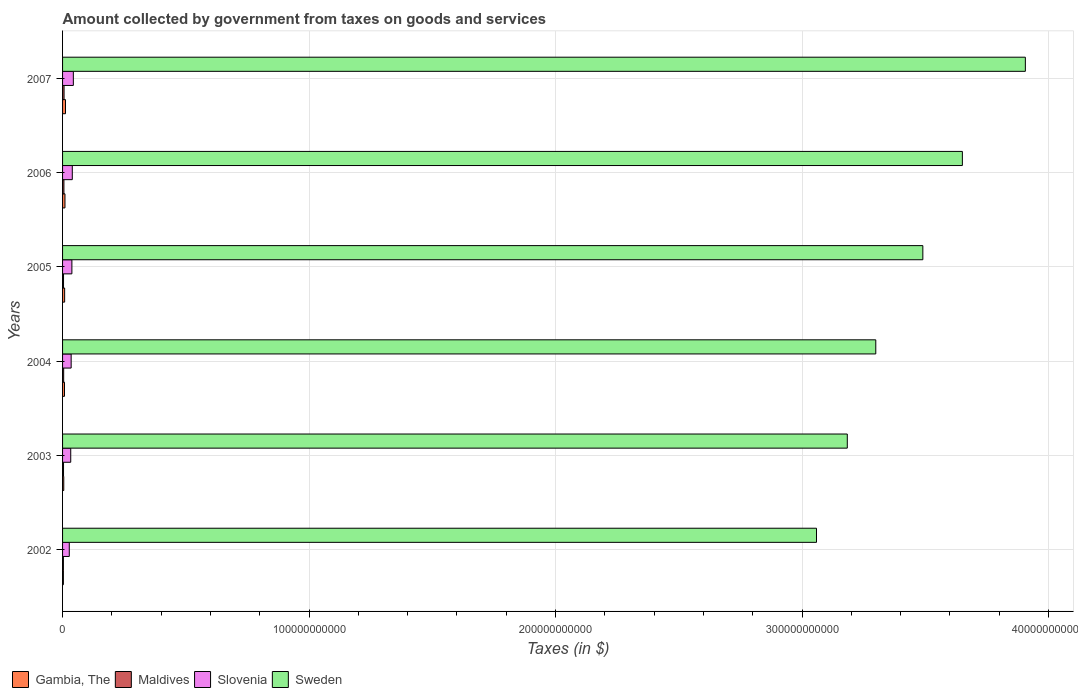How many groups of bars are there?
Your answer should be compact. 6. Are the number of bars per tick equal to the number of legend labels?
Provide a succinct answer. Yes. What is the label of the 4th group of bars from the top?
Give a very brief answer. 2004. In how many cases, is the number of bars for a given year not equal to the number of legend labels?
Your response must be concise. 0. What is the amount collected by government from taxes on goods and services in Maldives in 2005?
Keep it short and to the point. 3.91e+08. Across all years, what is the maximum amount collected by government from taxes on goods and services in Gambia, The?
Your answer should be compact. 1.19e+09. Across all years, what is the minimum amount collected by government from taxes on goods and services in Sweden?
Provide a succinct answer. 3.06e+11. In which year was the amount collected by government from taxes on goods and services in Maldives maximum?
Give a very brief answer. 2007. What is the total amount collected by government from taxes on goods and services in Sweden in the graph?
Provide a short and direct response. 2.06e+12. What is the difference between the amount collected by government from taxes on goods and services in Maldives in 2002 and that in 2005?
Your answer should be very brief. -5.26e+07. What is the difference between the amount collected by government from taxes on goods and services in Slovenia in 2005 and the amount collected by government from taxes on goods and services in Sweden in 2003?
Keep it short and to the point. -3.15e+11. What is the average amount collected by government from taxes on goods and services in Slovenia per year?
Offer a very short reply. 3.60e+09. In the year 2004, what is the difference between the amount collected by government from taxes on goods and services in Gambia, The and amount collected by government from taxes on goods and services in Sweden?
Provide a succinct answer. -3.29e+11. In how many years, is the amount collected by government from taxes on goods and services in Gambia, The greater than 300000000000 $?
Offer a terse response. 0. What is the ratio of the amount collected by government from taxes on goods and services in Sweden in 2003 to that in 2007?
Provide a succinct answer. 0.82. Is the amount collected by government from taxes on goods and services in Maldives in 2002 less than that in 2006?
Your response must be concise. Yes. What is the difference between the highest and the second highest amount collected by government from taxes on goods and services in Slovenia?
Keep it short and to the point. 4.23e+08. What is the difference between the highest and the lowest amount collected by government from taxes on goods and services in Maldives?
Ensure brevity in your answer.  2.69e+08. What does the 1st bar from the top in 2002 represents?
Your response must be concise. Sweden. What does the 4th bar from the bottom in 2003 represents?
Provide a short and direct response. Sweden. How many years are there in the graph?
Offer a very short reply. 6. What is the difference between two consecutive major ticks on the X-axis?
Your response must be concise. 1.00e+11. Are the values on the major ticks of X-axis written in scientific E-notation?
Provide a succinct answer. No. Does the graph contain grids?
Your answer should be very brief. Yes. Where does the legend appear in the graph?
Provide a short and direct response. Bottom left. How many legend labels are there?
Offer a very short reply. 4. What is the title of the graph?
Provide a short and direct response. Amount collected by government from taxes on goods and services. Does "Lebanon" appear as one of the legend labels in the graph?
Make the answer very short. No. What is the label or title of the X-axis?
Your answer should be very brief. Taxes (in $). What is the label or title of the Y-axis?
Your answer should be very brief. Years. What is the Taxes (in $) in Gambia, The in 2002?
Offer a terse response. 3.34e+08. What is the Taxes (in $) of Maldives in 2002?
Provide a short and direct response. 3.39e+08. What is the Taxes (in $) in Slovenia in 2002?
Keep it short and to the point. 2.72e+09. What is the Taxes (in $) in Sweden in 2002?
Ensure brevity in your answer.  3.06e+11. What is the Taxes (in $) of Gambia, The in 2003?
Provide a short and direct response. 4.84e+08. What is the Taxes (in $) in Maldives in 2003?
Ensure brevity in your answer.  3.95e+08. What is the Taxes (in $) of Slovenia in 2003?
Keep it short and to the point. 3.31e+09. What is the Taxes (in $) of Sweden in 2003?
Offer a terse response. 3.18e+11. What is the Taxes (in $) in Gambia, The in 2004?
Offer a very short reply. 7.87e+08. What is the Taxes (in $) of Maldives in 2004?
Ensure brevity in your answer.  4.50e+08. What is the Taxes (in $) in Slovenia in 2004?
Provide a succinct answer. 3.49e+09. What is the Taxes (in $) of Sweden in 2004?
Your answer should be compact. 3.30e+11. What is the Taxes (in $) of Gambia, The in 2005?
Your response must be concise. 8.43e+08. What is the Taxes (in $) in Maldives in 2005?
Ensure brevity in your answer.  3.91e+08. What is the Taxes (in $) of Slovenia in 2005?
Provide a succinct answer. 3.78e+09. What is the Taxes (in $) of Sweden in 2005?
Offer a terse response. 3.49e+11. What is the Taxes (in $) in Gambia, The in 2006?
Offer a very short reply. 9.76e+08. What is the Taxes (in $) of Maldives in 2006?
Your answer should be very brief. 5.49e+08. What is the Taxes (in $) in Slovenia in 2006?
Offer a very short reply. 3.95e+09. What is the Taxes (in $) in Sweden in 2006?
Your answer should be compact. 3.65e+11. What is the Taxes (in $) in Gambia, The in 2007?
Offer a very short reply. 1.19e+09. What is the Taxes (in $) of Maldives in 2007?
Provide a short and direct response. 6.08e+08. What is the Taxes (in $) in Slovenia in 2007?
Provide a succinct answer. 4.37e+09. What is the Taxes (in $) in Sweden in 2007?
Keep it short and to the point. 3.91e+11. Across all years, what is the maximum Taxes (in $) of Gambia, The?
Give a very brief answer. 1.19e+09. Across all years, what is the maximum Taxes (in $) in Maldives?
Provide a succinct answer. 6.08e+08. Across all years, what is the maximum Taxes (in $) of Slovenia?
Offer a terse response. 4.37e+09. Across all years, what is the maximum Taxes (in $) of Sweden?
Your response must be concise. 3.91e+11. Across all years, what is the minimum Taxes (in $) of Gambia, The?
Ensure brevity in your answer.  3.34e+08. Across all years, what is the minimum Taxes (in $) of Maldives?
Provide a short and direct response. 3.39e+08. Across all years, what is the minimum Taxes (in $) in Slovenia?
Provide a succinct answer. 2.72e+09. Across all years, what is the minimum Taxes (in $) of Sweden?
Ensure brevity in your answer.  3.06e+11. What is the total Taxes (in $) in Gambia, The in the graph?
Provide a succinct answer. 4.62e+09. What is the total Taxes (in $) of Maldives in the graph?
Make the answer very short. 2.73e+09. What is the total Taxes (in $) of Slovenia in the graph?
Ensure brevity in your answer.  2.16e+1. What is the total Taxes (in $) in Sweden in the graph?
Offer a very short reply. 2.06e+12. What is the difference between the Taxes (in $) of Gambia, The in 2002 and that in 2003?
Make the answer very short. -1.50e+08. What is the difference between the Taxes (in $) in Maldives in 2002 and that in 2003?
Your response must be concise. -5.62e+07. What is the difference between the Taxes (in $) of Slovenia in 2002 and that in 2003?
Make the answer very short. -5.88e+08. What is the difference between the Taxes (in $) in Sweden in 2002 and that in 2003?
Offer a terse response. -1.25e+1. What is the difference between the Taxes (in $) of Gambia, The in 2002 and that in 2004?
Make the answer very short. -4.52e+08. What is the difference between the Taxes (in $) of Maldives in 2002 and that in 2004?
Your answer should be compact. -1.12e+08. What is the difference between the Taxes (in $) in Slovenia in 2002 and that in 2004?
Make the answer very short. -7.65e+08. What is the difference between the Taxes (in $) in Sweden in 2002 and that in 2004?
Make the answer very short. -2.41e+1. What is the difference between the Taxes (in $) of Gambia, The in 2002 and that in 2005?
Make the answer very short. -5.09e+08. What is the difference between the Taxes (in $) of Maldives in 2002 and that in 2005?
Provide a succinct answer. -5.26e+07. What is the difference between the Taxes (in $) in Slovenia in 2002 and that in 2005?
Your answer should be compact. -1.06e+09. What is the difference between the Taxes (in $) in Sweden in 2002 and that in 2005?
Offer a very short reply. -4.31e+1. What is the difference between the Taxes (in $) of Gambia, The in 2002 and that in 2006?
Provide a succinct answer. -6.41e+08. What is the difference between the Taxes (in $) in Maldives in 2002 and that in 2006?
Your answer should be compact. -2.11e+08. What is the difference between the Taxes (in $) in Slovenia in 2002 and that in 2006?
Make the answer very short. -1.23e+09. What is the difference between the Taxes (in $) of Sweden in 2002 and that in 2006?
Provide a succinct answer. -5.92e+1. What is the difference between the Taxes (in $) in Gambia, The in 2002 and that in 2007?
Your response must be concise. -8.58e+08. What is the difference between the Taxes (in $) of Maldives in 2002 and that in 2007?
Your answer should be very brief. -2.69e+08. What is the difference between the Taxes (in $) of Slovenia in 2002 and that in 2007?
Your answer should be very brief. -1.65e+09. What is the difference between the Taxes (in $) in Sweden in 2002 and that in 2007?
Your response must be concise. -8.47e+1. What is the difference between the Taxes (in $) in Gambia, The in 2003 and that in 2004?
Ensure brevity in your answer.  -3.03e+08. What is the difference between the Taxes (in $) of Maldives in 2003 and that in 2004?
Offer a terse response. -5.57e+07. What is the difference between the Taxes (in $) of Slovenia in 2003 and that in 2004?
Provide a short and direct response. -1.77e+08. What is the difference between the Taxes (in $) of Sweden in 2003 and that in 2004?
Make the answer very short. -1.16e+1. What is the difference between the Taxes (in $) in Gambia, The in 2003 and that in 2005?
Provide a short and direct response. -3.59e+08. What is the difference between the Taxes (in $) in Maldives in 2003 and that in 2005?
Offer a very short reply. 3.60e+06. What is the difference between the Taxes (in $) in Slovenia in 2003 and that in 2005?
Ensure brevity in your answer.  -4.72e+08. What is the difference between the Taxes (in $) in Sweden in 2003 and that in 2005?
Ensure brevity in your answer.  -3.07e+1. What is the difference between the Taxes (in $) of Gambia, The in 2003 and that in 2006?
Give a very brief answer. -4.91e+08. What is the difference between the Taxes (in $) in Maldives in 2003 and that in 2006?
Offer a very short reply. -1.55e+08. What is the difference between the Taxes (in $) of Slovenia in 2003 and that in 2006?
Provide a succinct answer. -6.40e+08. What is the difference between the Taxes (in $) in Sweden in 2003 and that in 2006?
Your answer should be very brief. -4.67e+1. What is the difference between the Taxes (in $) of Gambia, The in 2003 and that in 2007?
Your answer should be very brief. -7.08e+08. What is the difference between the Taxes (in $) of Maldives in 2003 and that in 2007?
Your answer should be very brief. -2.13e+08. What is the difference between the Taxes (in $) of Slovenia in 2003 and that in 2007?
Make the answer very short. -1.06e+09. What is the difference between the Taxes (in $) in Sweden in 2003 and that in 2007?
Provide a succinct answer. -7.22e+1. What is the difference between the Taxes (in $) in Gambia, The in 2004 and that in 2005?
Your answer should be very brief. -5.66e+07. What is the difference between the Taxes (in $) of Maldives in 2004 and that in 2005?
Your answer should be compact. 5.93e+07. What is the difference between the Taxes (in $) of Slovenia in 2004 and that in 2005?
Your response must be concise. -2.96e+08. What is the difference between the Taxes (in $) in Sweden in 2004 and that in 2005?
Your response must be concise. -1.91e+1. What is the difference between the Taxes (in $) of Gambia, The in 2004 and that in 2006?
Give a very brief answer. -1.89e+08. What is the difference between the Taxes (in $) in Maldives in 2004 and that in 2006?
Keep it short and to the point. -9.89e+07. What is the difference between the Taxes (in $) in Slovenia in 2004 and that in 2006?
Provide a succinct answer. -4.63e+08. What is the difference between the Taxes (in $) of Sweden in 2004 and that in 2006?
Your answer should be compact. -3.51e+1. What is the difference between the Taxes (in $) in Gambia, The in 2004 and that in 2007?
Provide a short and direct response. -4.06e+08. What is the difference between the Taxes (in $) in Maldives in 2004 and that in 2007?
Make the answer very short. -1.57e+08. What is the difference between the Taxes (in $) of Slovenia in 2004 and that in 2007?
Offer a terse response. -8.86e+08. What is the difference between the Taxes (in $) of Sweden in 2004 and that in 2007?
Your answer should be very brief. -6.07e+1. What is the difference between the Taxes (in $) in Gambia, The in 2005 and that in 2006?
Provide a succinct answer. -1.32e+08. What is the difference between the Taxes (in $) of Maldives in 2005 and that in 2006?
Offer a terse response. -1.58e+08. What is the difference between the Taxes (in $) in Slovenia in 2005 and that in 2006?
Give a very brief answer. -1.67e+08. What is the difference between the Taxes (in $) of Sweden in 2005 and that in 2006?
Offer a terse response. -1.60e+1. What is the difference between the Taxes (in $) of Gambia, The in 2005 and that in 2007?
Offer a very short reply. -3.49e+08. What is the difference between the Taxes (in $) in Maldives in 2005 and that in 2007?
Make the answer very short. -2.17e+08. What is the difference between the Taxes (in $) in Slovenia in 2005 and that in 2007?
Your answer should be compact. -5.90e+08. What is the difference between the Taxes (in $) of Sweden in 2005 and that in 2007?
Provide a succinct answer. -4.16e+1. What is the difference between the Taxes (in $) in Gambia, The in 2006 and that in 2007?
Offer a terse response. -2.17e+08. What is the difference between the Taxes (in $) in Maldives in 2006 and that in 2007?
Provide a succinct answer. -5.84e+07. What is the difference between the Taxes (in $) in Slovenia in 2006 and that in 2007?
Your answer should be very brief. -4.23e+08. What is the difference between the Taxes (in $) in Sweden in 2006 and that in 2007?
Provide a succinct answer. -2.55e+1. What is the difference between the Taxes (in $) of Gambia, The in 2002 and the Taxes (in $) of Maldives in 2003?
Provide a succinct answer. -6.03e+07. What is the difference between the Taxes (in $) of Gambia, The in 2002 and the Taxes (in $) of Slovenia in 2003?
Your answer should be very brief. -2.98e+09. What is the difference between the Taxes (in $) of Gambia, The in 2002 and the Taxes (in $) of Sweden in 2003?
Your answer should be very brief. -3.18e+11. What is the difference between the Taxes (in $) of Maldives in 2002 and the Taxes (in $) of Slovenia in 2003?
Offer a terse response. -2.97e+09. What is the difference between the Taxes (in $) of Maldives in 2002 and the Taxes (in $) of Sweden in 2003?
Give a very brief answer. -3.18e+11. What is the difference between the Taxes (in $) of Slovenia in 2002 and the Taxes (in $) of Sweden in 2003?
Offer a terse response. -3.16e+11. What is the difference between the Taxes (in $) in Gambia, The in 2002 and the Taxes (in $) in Maldives in 2004?
Your response must be concise. -1.16e+08. What is the difference between the Taxes (in $) of Gambia, The in 2002 and the Taxes (in $) of Slovenia in 2004?
Give a very brief answer. -3.15e+09. What is the difference between the Taxes (in $) of Gambia, The in 2002 and the Taxes (in $) of Sweden in 2004?
Give a very brief answer. -3.30e+11. What is the difference between the Taxes (in $) in Maldives in 2002 and the Taxes (in $) in Slovenia in 2004?
Give a very brief answer. -3.15e+09. What is the difference between the Taxes (in $) in Maldives in 2002 and the Taxes (in $) in Sweden in 2004?
Provide a short and direct response. -3.30e+11. What is the difference between the Taxes (in $) in Slovenia in 2002 and the Taxes (in $) in Sweden in 2004?
Provide a short and direct response. -3.27e+11. What is the difference between the Taxes (in $) of Gambia, The in 2002 and the Taxes (in $) of Maldives in 2005?
Ensure brevity in your answer.  -5.67e+07. What is the difference between the Taxes (in $) in Gambia, The in 2002 and the Taxes (in $) in Slovenia in 2005?
Keep it short and to the point. -3.45e+09. What is the difference between the Taxes (in $) of Gambia, The in 2002 and the Taxes (in $) of Sweden in 2005?
Offer a very short reply. -3.49e+11. What is the difference between the Taxes (in $) of Maldives in 2002 and the Taxes (in $) of Slovenia in 2005?
Provide a short and direct response. -3.44e+09. What is the difference between the Taxes (in $) in Maldives in 2002 and the Taxes (in $) in Sweden in 2005?
Provide a short and direct response. -3.49e+11. What is the difference between the Taxes (in $) of Slovenia in 2002 and the Taxes (in $) of Sweden in 2005?
Offer a very short reply. -3.46e+11. What is the difference between the Taxes (in $) in Gambia, The in 2002 and the Taxes (in $) in Maldives in 2006?
Your response must be concise. -2.15e+08. What is the difference between the Taxes (in $) of Gambia, The in 2002 and the Taxes (in $) of Slovenia in 2006?
Your response must be concise. -3.62e+09. What is the difference between the Taxes (in $) in Gambia, The in 2002 and the Taxes (in $) in Sweden in 2006?
Offer a terse response. -3.65e+11. What is the difference between the Taxes (in $) of Maldives in 2002 and the Taxes (in $) of Slovenia in 2006?
Offer a terse response. -3.61e+09. What is the difference between the Taxes (in $) of Maldives in 2002 and the Taxes (in $) of Sweden in 2006?
Offer a terse response. -3.65e+11. What is the difference between the Taxes (in $) in Slovenia in 2002 and the Taxes (in $) in Sweden in 2006?
Offer a terse response. -3.62e+11. What is the difference between the Taxes (in $) of Gambia, The in 2002 and the Taxes (in $) of Maldives in 2007?
Give a very brief answer. -2.73e+08. What is the difference between the Taxes (in $) of Gambia, The in 2002 and the Taxes (in $) of Slovenia in 2007?
Keep it short and to the point. -4.04e+09. What is the difference between the Taxes (in $) in Gambia, The in 2002 and the Taxes (in $) in Sweden in 2007?
Keep it short and to the point. -3.90e+11. What is the difference between the Taxes (in $) of Maldives in 2002 and the Taxes (in $) of Slovenia in 2007?
Provide a short and direct response. -4.04e+09. What is the difference between the Taxes (in $) in Maldives in 2002 and the Taxes (in $) in Sweden in 2007?
Offer a terse response. -3.90e+11. What is the difference between the Taxes (in $) of Slovenia in 2002 and the Taxes (in $) of Sweden in 2007?
Provide a succinct answer. -3.88e+11. What is the difference between the Taxes (in $) of Gambia, The in 2003 and the Taxes (in $) of Maldives in 2004?
Your answer should be compact. 3.37e+07. What is the difference between the Taxes (in $) of Gambia, The in 2003 and the Taxes (in $) of Slovenia in 2004?
Give a very brief answer. -3.00e+09. What is the difference between the Taxes (in $) of Gambia, The in 2003 and the Taxes (in $) of Sweden in 2004?
Provide a short and direct response. -3.29e+11. What is the difference between the Taxes (in $) in Maldives in 2003 and the Taxes (in $) in Slovenia in 2004?
Your answer should be compact. -3.09e+09. What is the difference between the Taxes (in $) of Maldives in 2003 and the Taxes (in $) of Sweden in 2004?
Your response must be concise. -3.30e+11. What is the difference between the Taxes (in $) in Slovenia in 2003 and the Taxes (in $) in Sweden in 2004?
Your response must be concise. -3.27e+11. What is the difference between the Taxes (in $) of Gambia, The in 2003 and the Taxes (in $) of Maldives in 2005?
Keep it short and to the point. 9.30e+07. What is the difference between the Taxes (in $) of Gambia, The in 2003 and the Taxes (in $) of Slovenia in 2005?
Make the answer very short. -3.30e+09. What is the difference between the Taxes (in $) of Gambia, The in 2003 and the Taxes (in $) of Sweden in 2005?
Provide a succinct answer. -3.49e+11. What is the difference between the Taxes (in $) of Maldives in 2003 and the Taxes (in $) of Slovenia in 2005?
Offer a very short reply. -3.39e+09. What is the difference between the Taxes (in $) of Maldives in 2003 and the Taxes (in $) of Sweden in 2005?
Offer a terse response. -3.49e+11. What is the difference between the Taxes (in $) in Slovenia in 2003 and the Taxes (in $) in Sweden in 2005?
Keep it short and to the point. -3.46e+11. What is the difference between the Taxes (in $) in Gambia, The in 2003 and the Taxes (in $) in Maldives in 2006?
Keep it short and to the point. -6.52e+07. What is the difference between the Taxes (in $) in Gambia, The in 2003 and the Taxes (in $) in Slovenia in 2006?
Provide a short and direct response. -3.47e+09. What is the difference between the Taxes (in $) of Gambia, The in 2003 and the Taxes (in $) of Sweden in 2006?
Give a very brief answer. -3.65e+11. What is the difference between the Taxes (in $) of Maldives in 2003 and the Taxes (in $) of Slovenia in 2006?
Offer a terse response. -3.56e+09. What is the difference between the Taxes (in $) in Maldives in 2003 and the Taxes (in $) in Sweden in 2006?
Make the answer very short. -3.65e+11. What is the difference between the Taxes (in $) of Slovenia in 2003 and the Taxes (in $) of Sweden in 2006?
Your answer should be very brief. -3.62e+11. What is the difference between the Taxes (in $) in Gambia, The in 2003 and the Taxes (in $) in Maldives in 2007?
Offer a terse response. -1.24e+08. What is the difference between the Taxes (in $) of Gambia, The in 2003 and the Taxes (in $) of Slovenia in 2007?
Your answer should be compact. -3.89e+09. What is the difference between the Taxes (in $) in Gambia, The in 2003 and the Taxes (in $) in Sweden in 2007?
Your answer should be compact. -3.90e+11. What is the difference between the Taxes (in $) of Maldives in 2003 and the Taxes (in $) of Slovenia in 2007?
Ensure brevity in your answer.  -3.98e+09. What is the difference between the Taxes (in $) in Maldives in 2003 and the Taxes (in $) in Sweden in 2007?
Provide a succinct answer. -3.90e+11. What is the difference between the Taxes (in $) in Slovenia in 2003 and the Taxes (in $) in Sweden in 2007?
Ensure brevity in your answer.  -3.87e+11. What is the difference between the Taxes (in $) of Gambia, The in 2004 and the Taxes (in $) of Maldives in 2005?
Your response must be concise. 3.96e+08. What is the difference between the Taxes (in $) of Gambia, The in 2004 and the Taxes (in $) of Slovenia in 2005?
Provide a short and direct response. -3.00e+09. What is the difference between the Taxes (in $) in Gambia, The in 2004 and the Taxes (in $) in Sweden in 2005?
Offer a very short reply. -3.48e+11. What is the difference between the Taxes (in $) in Maldives in 2004 and the Taxes (in $) in Slovenia in 2005?
Provide a short and direct response. -3.33e+09. What is the difference between the Taxes (in $) of Maldives in 2004 and the Taxes (in $) of Sweden in 2005?
Provide a succinct answer. -3.49e+11. What is the difference between the Taxes (in $) in Slovenia in 2004 and the Taxes (in $) in Sweden in 2005?
Give a very brief answer. -3.46e+11. What is the difference between the Taxes (in $) of Gambia, The in 2004 and the Taxes (in $) of Maldives in 2006?
Ensure brevity in your answer.  2.37e+08. What is the difference between the Taxes (in $) of Gambia, The in 2004 and the Taxes (in $) of Slovenia in 2006?
Offer a terse response. -3.16e+09. What is the difference between the Taxes (in $) of Gambia, The in 2004 and the Taxes (in $) of Sweden in 2006?
Your answer should be very brief. -3.64e+11. What is the difference between the Taxes (in $) in Maldives in 2004 and the Taxes (in $) in Slovenia in 2006?
Offer a terse response. -3.50e+09. What is the difference between the Taxes (in $) in Maldives in 2004 and the Taxes (in $) in Sweden in 2006?
Your answer should be compact. -3.65e+11. What is the difference between the Taxes (in $) in Slovenia in 2004 and the Taxes (in $) in Sweden in 2006?
Offer a very short reply. -3.62e+11. What is the difference between the Taxes (in $) of Gambia, The in 2004 and the Taxes (in $) of Maldives in 2007?
Your answer should be compact. 1.79e+08. What is the difference between the Taxes (in $) in Gambia, The in 2004 and the Taxes (in $) in Slovenia in 2007?
Your response must be concise. -3.59e+09. What is the difference between the Taxes (in $) of Gambia, The in 2004 and the Taxes (in $) of Sweden in 2007?
Your answer should be very brief. -3.90e+11. What is the difference between the Taxes (in $) of Maldives in 2004 and the Taxes (in $) of Slovenia in 2007?
Your response must be concise. -3.92e+09. What is the difference between the Taxes (in $) of Maldives in 2004 and the Taxes (in $) of Sweden in 2007?
Give a very brief answer. -3.90e+11. What is the difference between the Taxes (in $) of Slovenia in 2004 and the Taxes (in $) of Sweden in 2007?
Give a very brief answer. -3.87e+11. What is the difference between the Taxes (in $) in Gambia, The in 2005 and the Taxes (in $) in Maldives in 2006?
Your response must be concise. 2.94e+08. What is the difference between the Taxes (in $) of Gambia, The in 2005 and the Taxes (in $) of Slovenia in 2006?
Offer a very short reply. -3.11e+09. What is the difference between the Taxes (in $) in Gambia, The in 2005 and the Taxes (in $) in Sweden in 2006?
Your response must be concise. -3.64e+11. What is the difference between the Taxes (in $) in Maldives in 2005 and the Taxes (in $) in Slovenia in 2006?
Your answer should be compact. -3.56e+09. What is the difference between the Taxes (in $) of Maldives in 2005 and the Taxes (in $) of Sweden in 2006?
Offer a very short reply. -3.65e+11. What is the difference between the Taxes (in $) of Slovenia in 2005 and the Taxes (in $) of Sweden in 2006?
Provide a short and direct response. -3.61e+11. What is the difference between the Taxes (in $) of Gambia, The in 2005 and the Taxes (in $) of Maldives in 2007?
Provide a succinct answer. 2.36e+08. What is the difference between the Taxes (in $) of Gambia, The in 2005 and the Taxes (in $) of Slovenia in 2007?
Your answer should be compact. -3.53e+09. What is the difference between the Taxes (in $) of Gambia, The in 2005 and the Taxes (in $) of Sweden in 2007?
Your response must be concise. -3.90e+11. What is the difference between the Taxes (in $) of Maldives in 2005 and the Taxes (in $) of Slovenia in 2007?
Your answer should be very brief. -3.98e+09. What is the difference between the Taxes (in $) in Maldives in 2005 and the Taxes (in $) in Sweden in 2007?
Offer a terse response. -3.90e+11. What is the difference between the Taxes (in $) of Slovenia in 2005 and the Taxes (in $) of Sweden in 2007?
Your response must be concise. -3.87e+11. What is the difference between the Taxes (in $) of Gambia, The in 2006 and the Taxes (in $) of Maldives in 2007?
Make the answer very short. 3.68e+08. What is the difference between the Taxes (in $) of Gambia, The in 2006 and the Taxes (in $) of Slovenia in 2007?
Ensure brevity in your answer.  -3.40e+09. What is the difference between the Taxes (in $) in Gambia, The in 2006 and the Taxes (in $) in Sweden in 2007?
Make the answer very short. -3.90e+11. What is the difference between the Taxes (in $) in Maldives in 2006 and the Taxes (in $) in Slovenia in 2007?
Provide a short and direct response. -3.82e+09. What is the difference between the Taxes (in $) in Maldives in 2006 and the Taxes (in $) in Sweden in 2007?
Ensure brevity in your answer.  -3.90e+11. What is the difference between the Taxes (in $) in Slovenia in 2006 and the Taxes (in $) in Sweden in 2007?
Make the answer very short. -3.87e+11. What is the average Taxes (in $) of Gambia, The per year?
Provide a short and direct response. 7.69e+08. What is the average Taxes (in $) in Maldives per year?
Offer a very short reply. 4.55e+08. What is the average Taxes (in $) of Slovenia per year?
Offer a terse response. 3.60e+09. What is the average Taxes (in $) in Sweden per year?
Keep it short and to the point. 3.43e+11. In the year 2002, what is the difference between the Taxes (in $) in Gambia, The and Taxes (in $) in Maldives?
Offer a very short reply. -4.10e+06. In the year 2002, what is the difference between the Taxes (in $) of Gambia, The and Taxes (in $) of Slovenia?
Ensure brevity in your answer.  -2.39e+09. In the year 2002, what is the difference between the Taxes (in $) of Gambia, The and Taxes (in $) of Sweden?
Offer a very short reply. -3.06e+11. In the year 2002, what is the difference between the Taxes (in $) of Maldives and Taxes (in $) of Slovenia?
Provide a short and direct response. -2.38e+09. In the year 2002, what is the difference between the Taxes (in $) of Maldives and Taxes (in $) of Sweden?
Your answer should be very brief. -3.06e+11. In the year 2002, what is the difference between the Taxes (in $) of Slovenia and Taxes (in $) of Sweden?
Your answer should be very brief. -3.03e+11. In the year 2003, what is the difference between the Taxes (in $) of Gambia, The and Taxes (in $) of Maldives?
Give a very brief answer. 8.94e+07. In the year 2003, what is the difference between the Taxes (in $) of Gambia, The and Taxes (in $) of Slovenia?
Your response must be concise. -2.83e+09. In the year 2003, what is the difference between the Taxes (in $) of Gambia, The and Taxes (in $) of Sweden?
Ensure brevity in your answer.  -3.18e+11. In the year 2003, what is the difference between the Taxes (in $) in Maldives and Taxes (in $) in Slovenia?
Offer a very short reply. -2.92e+09. In the year 2003, what is the difference between the Taxes (in $) of Maldives and Taxes (in $) of Sweden?
Your answer should be very brief. -3.18e+11. In the year 2003, what is the difference between the Taxes (in $) of Slovenia and Taxes (in $) of Sweden?
Your answer should be very brief. -3.15e+11. In the year 2004, what is the difference between the Taxes (in $) of Gambia, The and Taxes (in $) of Maldives?
Keep it short and to the point. 3.36e+08. In the year 2004, what is the difference between the Taxes (in $) of Gambia, The and Taxes (in $) of Slovenia?
Keep it short and to the point. -2.70e+09. In the year 2004, what is the difference between the Taxes (in $) in Gambia, The and Taxes (in $) in Sweden?
Offer a very short reply. -3.29e+11. In the year 2004, what is the difference between the Taxes (in $) in Maldives and Taxes (in $) in Slovenia?
Make the answer very short. -3.04e+09. In the year 2004, what is the difference between the Taxes (in $) of Maldives and Taxes (in $) of Sweden?
Ensure brevity in your answer.  -3.29e+11. In the year 2004, what is the difference between the Taxes (in $) in Slovenia and Taxes (in $) in Sweden?
Give a very brief answer. -3.26e+11. In the year 2005, what is the difference between the Taxes (in $) of Gambia, The and Taxes (in $) of Maldives?
Offer a very short reply. 4.52e+08. In the year 2005, what is the difference between the Taxes (in $) in Gambia, The and Taxes (in $) in Slovenia?
Keep it short and to the point. -2.94e+09. In the year 2005, what is the difference between the Taxes (in $) in Gambia, The and Taxes (in $) in Sweden?
Ensure brevity in your answer.  -3.48e+11. In the year 2005, what is the difference between the Taxes (in $) of Maldives and Taxes (in $) of Slovenia?
Your answer should be very brief. -3.39e+09. In the year 2005, what is the difference between the Taxes (in $) in Maldives and Taxes (in $) in Sweden?
Offer a terse response. -3.49e+11. In the year 2005, what is the difference between the Taxes (in $) in Slovenia and Taxes (in $) in Sweden?
Offer a very short reply. -3.45e+11. In the year 2006, what is the difference between the Taxes (in $) of Gambia, The and Taxes (in $) of Maldives?
Provide a short and direct response. 4.26e+08. In the year 2006, what is the difference between the Taxes (in $) in Gambia, The and Taxes (in $) in Slovenia?
Provide a short and direct response. -2.98e+09. In the year 2006, what is the difference between the Taxes (in $) of Gambia, The and Taxes (in $) of Sweden?
Your response must be concise. -3.64e+11. In the year 2006, what is the difference between the Taxes (in $) of Maldives and Taxes (in $) of Slovenia?
Give a very brief answer. -3.40e+09. In the year 2006, what is the difference between the Taxes (in $) in Maldives and Taxes (in $) in Sweden?
Provide a succinct answer. -3.65e+11. In the year 2006, what is the difference between the Taxes (in $) in Slovenia and Taxes (in $) in Sweden?
Offer a terse response. -3.61e+11. In the year 2007, what is the difference between the Taxes (in $) in Gambia, The and Taxes (in $) in Maldives?
Ensure brevity in your answer.  5.85e+08. In the year 2007, what is the difference between the Taxes (in $) of Gambia, The and Taxes (in $) of Slovenia?
Keep it short and to the point. -3.18e+09. In the year 2007, what is the difference between the Taxes (in $) of Gambia, The and Taxes (in $) of Sweden?
Give a very brief answer. -3.89e+11. In the year 2007, what is the difference between the Taxes (in $) in Maldives and Taxes (in $) in Slovenia?
Offer a terse response. -3.77e+09. In the year 2007, what is the difference between the Taxes (in $) in Maldives and Taxes (in $) in Sweden?
Your answer should be very brief. -3.90e+11. In the year 2007, what is the difference between the Taxes (in $) in Slovenia and Taxes (in $) in Sweden?
Keep it short and to the point. -3.86e+11. What is the ratio of the Taxes (in $) in Gambia, The in 2002 to that in 2003?
Ensure brevity in your answer.  0.69. What is the ratio of the Taxes (in $) in Maldives in 2002 to that in 2003?
Your answer should be very brief. 0.86. What is the ratio of the Taxes (in $) in Slovenia in 2002 to that in 2003?
Your response must be concise. 0.82. What is the ratio of the Taxes (in $) of Sweden in 2002 to that in 2003?
Offer a very short reply. 0.96. What is the ratio of the Taxes (in $) in Gambia, The in 2002 to that in 2004?
Give a very brief answer. 0.43. What is the ratio of the Taxes (in $) of Maldives in 2002 to that in 2004?
Your answer should be compact. 0.75. What is the ratio of the Taxes (in $) of Slovenia in 2002 to that in 2004?
Your answer should be very brief. 0.78. What is the ratio of the Taxes (in $) in Sweden in 2002 to that in 2004?
Offer a terse response. 0.93. What is the ratio of the Taxes (in $) in Gambia, The in 2002 to that in 2005?
Your answer should be compact. 0.4. What is the ratio of the Taxes (in $) of Maldives in 2002 to that in 2005?
Provide a short and direct response. 0.87. What is the ratio of the Taxes (in $) of Slovenia in 2002 to that in 2005?
Offer a terse response. 0.72. What is the ratio of the Taxes (in $) in Sweden in 2002 to that in 2005?
Give a very brief answer. 0.88. What is the ratio of the Taxes (in $) of Gambia, The in 2002 to that in 2006?
Offer a terse response. 0.34. What is the ratio of the Taxes (in $) of Maldives in 2002 to that in 2006?
Ensure brevity in your answer.  0.62. What is the ratio of the Taxes (in $) in Slovenia in 2002 to that in 2006?
Ensure brevity in your answer.  0.69. What is the ratio of the Taxes (in $) of Sweden in 2002 to that in 2006?
Your answer should be compact. 0.84. What is the ratio of the Taxes (in $) in Gambia, The in 2002 to that in 2007?
Make the answer very short. 0.28. What is the ratio of the Taxes (in $) in Maldives in 2002 to that in 2007?
Ensure brevity in your answer.  0.56. What is the ratio of the Taxes (in $) in Slovenia in 2002 to that in 2007?
Keep it short and to the point. 0.62. What is the ratio of the Taxes (in $) in Sweden in 2002 to that in 2007?
Provide a short and direct response. 0.78. What is the ratio of the Taxes (in $) in Gambia, The in 2003 to that in 2004?
Provide a short and direct response. 0.62. What is the ratio of the Taxes (in $) of Maldives in 2003 to that in 2004?
Ensure brevity in your answer.  0.88. What is the ratio of the Taxes (in $) of Slovenia in 2003 to that in 2004?
Make the answer very short. 0.95. What is the ratio of the Taxes (in $) in Sweden in 2003 to that in 2004?
Offer a very short reply. 0.96. What is the ratio of the Taxes (in $) of Gambia, The in 2003 to that in 2005?
Your answer should be very brief. 0.57. What is the ratio of the Taxes (in $) in Maldives in 2003 to that in 2005?
Your answer should be very brief. 1.01. What is the ratio of the Taxes (in $) of Slovenia in 2003 to that in 2005?
Provide a short and direct response. 0.88. What is the ratio of the Taxes (in $) in Sweden in 2003 to that in 2005?
Your answer should be very brief. 0.91. What is the ratio of the Taxes (in $) of Gambia, The in 2003 to that in 2006?
Offer a terse response. 0.5. What is the ratio of the Taxes (in $) of Maldives in 2003 to that in 2006?
Your answer should be compact. 0.72. What is the ratio of the Taxes (in $) of Slovenia in 2003 to that in 2006?
Make the answer very short. 0.84. What is the ratio of the Taxes (in $) of Sweden in 2003 to that in 2006?
Offer a terse response. 0.87. What is the ratio of the Taxes (in $) of Gambia, The in 2003 to that in 2007?
Your answer should be very brief. 0.41. What is the ratio of the Taxes (in $) in Maldives in 2003 to that in 2007?
Your answer should be compact. 0.65. What is the ratio of the Taxes (in $) in Slovenia in 2003 to that in 2007?
Your answer should be compact. 0.76. What is the ratio of the Taxes (in $) in Sweden in 2003 to that in 2007?
Provide a short and direct response. 0.82. What is the ratio of the Taxes (in $) of Gambia, The in 2004 to that in 2005?
Keep it short and to the point. 0.93. What is the ratio of the Taxes (in $) in Maldives in 2004 to that in 2005?
Provide a short and direct response. 1.15. What is the ratio of the Taxes (in $) in Slovenia in 2004 to that in 2005?
Ensure brevity in your answer.  0.92. What is the ratio of the Taxes (in $) of Sweden in 2004 to that in 2005?
Provide a short and direct response. 0.95. What is the ratio of the Taxes (in $) of Gambia, The in 2004 to that in 2006?
Make the answer very short. 0.81. What is the ratio of the Taxes (in $) in Maldives in 2004 to that in 2006?
Provide a short and direct response. 0.82. What is the ratio of the Taxes (in $) of Slovenia in 2004 to that in 2006?
Give a very brief answer. 0.88. What is the ratio of the Taxes (in $) of Sweden in 2004 to that in 2006?
Make the answer very short. 0.9. What is the ratio of the Taxes (in $) of Gambia, The in 2004 to that in 2007?
Provide a short and direct response. 0.66. What is the ratio of the Taxes (in $) in Maldives in 2004 to that in 2007?
Your answer should be compact. 0.74. What is the ratio of the Taxes (in $) in Slovenia in 2004 to that in 2007?
Provide a succinct answer. 0.8. What is the ratio of the Taxes (in $) of Sweden in 2004 to that in 2007?
Provide a short and direct response. 0.84. What is the ratio of the Taxes (in $) of Gambia, The in 2005 to that in 2006?
Ensure brevity in your answer.  0.86. What is the ratio of the Taxes (in $) in Maldives in 2005 to that in 2006?
Provide a short and direct response. 0.71. What is the ratio of the Taxes (in $) of Slovenia in 2005 to that in 2006?
Your response must be concise. 0.96. What is the ratio of the Taxes (in $) in Sweden in 2005 to that in 2006?
Provide a short and direct response. 0.96. What is the ratio of the Taxes (in $) of Gambia, The in 2005 to that in 2007?
Provide a short and direct response. 0.71. What is the ratio of the Taxes (in $) of Maldives in 2005 to that in 2007?
Ensure brevity in your answer.  0.64. What is the ratio of the Taxes (in $) in Slovenia in 2005 to that in 2007?
Keep it short and to the point. 0.86. What is the ratio of the Taxes (in $) of Sweden in 2005 to that in 2007?
Give a very brief answer. 0.89. What is the ratio of the Taxes (in $) in Gambia, The in 2006 to that in 2007?
Your response must be concise. 0.82. What is the ratio of the Taxes (in $) in Maldives in 2006 to that in 2007?
Provide a short and direct response. 0.9. What is the ratio of the Taxes (in $) in Slovenia in 2006 to that in 2007?
Offer a very short reply. 0.9. What is the ratio of the Taxes (in $) of Sweden in 2006 to that in 2007?
Your response must be concise. 0.93. What is the difference between the highest and the second highest Taxes (in $) of Gambia, The?
Your response must be concise. 2.17e+08. What is the difference between the highest and the second highest Taxes (in $) in Maldives?
Your response must be concise. 5.84e+07. What is the difference between the highest and the second highest Taxes (in $) in Slovenia?
Ensure brevity in your answer.  4.23e+08. What is the difference between the highest and the second highest Taxes (in $) of Sweden?
Your answer should be compact. 2.55e+1. What is the difference between the highest and the lowest Taxes (in $) in Gambia, The?
Provide a short and direct response. 8.58e+08. What is the difference between the highest and the lowest Taxes (in $) of Maldives?
Provide a short and direct response. 2.69e+08. What is the difference between the highest and the lowest Taxes (in $) in Slovenia?
Offer a very short reply. 1.65e+09. What is the difference between the highest and the lowest Taxes (in $) in Sweden?
Make the answer very short. 8.47e+1. 